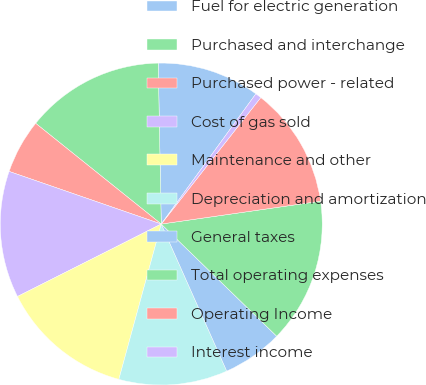Convert chart. <chart><loc_0><loc_0><loc_500><loc_500><pie_chart><fcel>Fuel for electric generation<fcel>Purchased and interchange<fcel>Purchased power - related<fcel>Cost of gas sold<fcel>Maintenance and other<fcel>Depreciation and amortization<fcel>General taxes<fcel>Total operating expenses<fcel>Operating Income<fcel>Interest income<nl><fcel>10.3%<fcel>13.94%<fcel>5.46%<fcel>12.73%<fcel>13.33%<fcel>10.91%<fcel>6.06%<fcel>14.54%<fcel>12.12%<fcel>0.61%<nl></chart> 